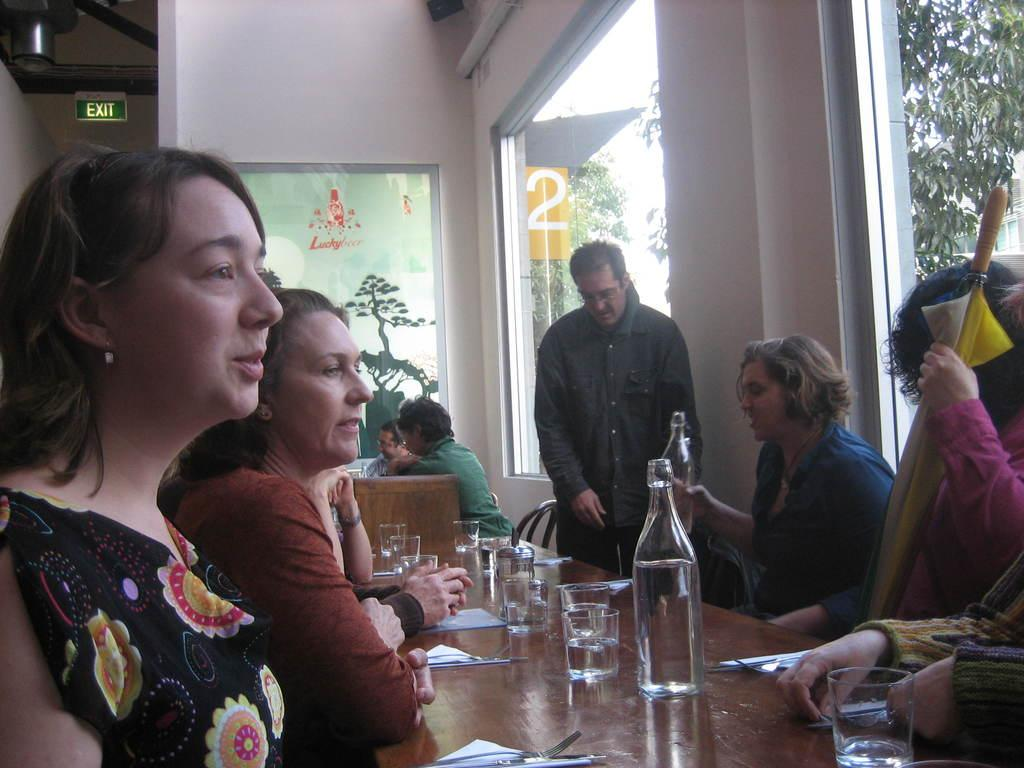How many people are in the image? There is a group of people in the image. What are the people doing in the image? The people are sitting on chairs. What is on the table in the image? There is a glass, a bottle, and a paper on the table. What can be seen in the background of the image? There are windows and trees visible in the background of the image. What type of cloth is draped over the thought in the image? There is no cloth or thought present in the image. How does the growth of the trees affect the people in the image? The image does not show any growth of trees or any impact on the people. 